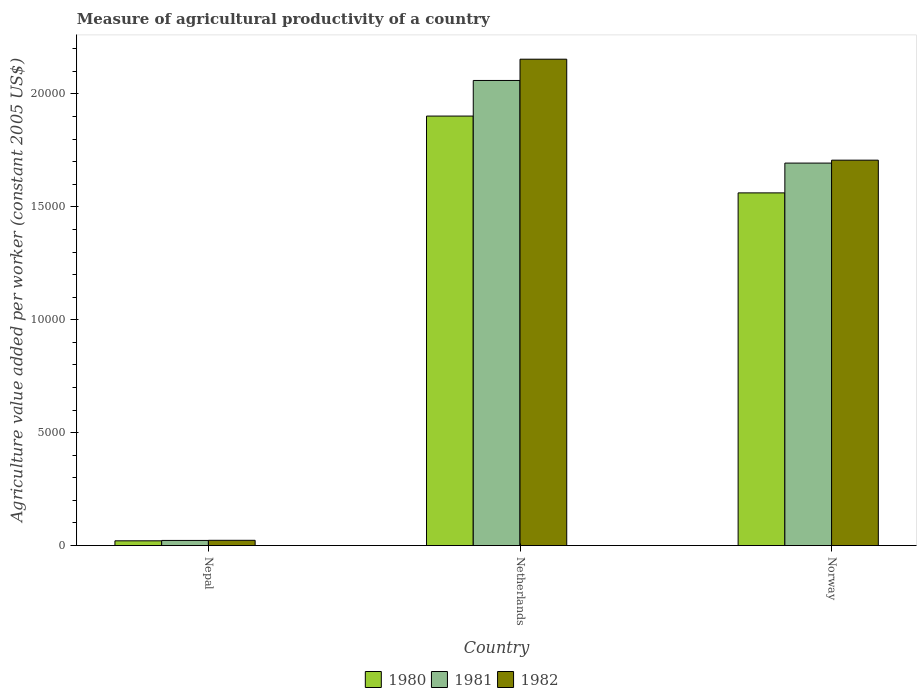How many different coloured bars are there?
Your response must be concise. 3. Are the number of bars per tick equal to the number of legend labels?
Your answer should be very brief. Yes. How many bars are there on the 2nd tick from the left?
Provide a short and direct response. 3. How many bars are there on the 2nd tick from the right?
Offer a terse response. 3. What is the label of the 1st group of bars from the left?
Your answer should be compact. Nepal. In how many cases, is the number of bars for a given country not equal to the number of legend labels?
Your response must be concise. 0. What is the measure of agricultural productivity in 1980 in Nepal?
Provide a short and direct response. 210.09. Across all countries, what is the maximum measure of agricultural productivity in 1981?
Offer a very short reply. 2.06e+04. Across all countries, what is the minimum measure of agricultural productivity in 1982?
Ensure brevity in your answer.  232.83. In which country was the measure of agricultural productivity in 1982 minimum?
Provide a short and direct response. Nepal. What is the total measure of agricultural productivity in 1982 in the graph?
Your response must be concise. 3.88e+04. What is the difference between the measure of agricultural productivity in 1981 in Nepal and that in Netherlands?
Provide a succinct answer. -2.04e+04. What is the difference between the measure of agricultural productivity in 1982 in Nepal and the measure of agricultural productivity in 1981 in Norway?
Make the answer very short. -1.67e+04. What is the average measure of agricultural productivity in 1980 per country?
Your answer should be very brief. 1.16e+04. What is the difference between the measure of agricultural productivity of/in 1982 and measure of agricultural productivity of/in 1980 in Nepal?
Offer a terse response. 22.74. What is the ratio of the measure of agricultural productivity in 1982 in Netherlands to that in Norway?
Keep it short and to the point. 1.26. Is the measure of agricultural productivity in 1980 in Nepal less than that in Netherlands?
Offer a terse response. Yes. What is the difference between the highest and the second highest measure of agricultural productivity in 1980?
Keep it short and to the point. 1.54e+04. What is the difference between the highest and the lowest measure of agricultural productivity in 1982?
Your response must be concise. 2.13e+04. In how many countries, is the measure of agricultural productivity in 1981 greater than the average measure of agricultural productivity in 1981 taken over all countries?
Ensure brevity in your answer.  2. What does the 1st bar from the right in Netherlands represents?
Give a very brief answer. 1982. Is it the case that in every country, the sum of the measure of agricultural productivity in 1981 and measure of agricultural productivity in 1980 is greater than the measure of agricultural productivity in 1982?
Your answer should be very brief. Yes. Are all the bars in the graph horizontal?
Offer a terse response. No. Does the graph contain any zero values?
Your response must be concise. No. Does the graph contain grids?
Make the answer very short. No. Where does the legend appear in the graph?
Provide a short and direct response. Bottom center. How are the legend labels stacked?
Ensure brevity in your answer.  Horizontal. What is the title of the graph?
Keep it short and to the point. Measure of agricultural productivity of a country. Does "2013" appear as one of the legend labels in the graph?
Provide a short and direct response. No. What is the label or title of the X-axis?
Your response must be concise. Country. What is the label or title of the Y-axis?
Your response must be concise. Agriculture value added per worker (constant 2005 US$). What is the Agriculture value added per worker (constant 2005 US$) of 1980 in Nepal?
Your answer should be very brief. 210.09. What is the Agriculture value added per worker (constant 2005 US$) of 1981 in Nepal?
Your answer should be very brief. 227.07. What is the Agriculture value added per worker (constant 2005 US$) in 1982 in Nepal?
Ensure brevity in your answer.  232.83. What is the Agriculture value added per worker (constant 2005 US$) in 1980 in Netherlands?
Provide a short and direct response. 1.90e+04. What is the Agriculture value added per worker (constant 2005 US$) of 1981 in Netherlands?
Offer a very short reply. 2.06e+04. What is the Agriculture value added per worker (constant 2005 US$) of 1982 in Netherlands?
Make the answer very short. 2.15e+04. What is the Agriculture value added per worker (constant 2005 US$) of 1980 in Norway?
Your answer should be compact. 1.56e+04. What is the Agriculture value added per worker (constant 2005 US$) in 1981 in Norway?
Your answer should be very brief. 1.69e+04. What is the Agriculture value added per worker (constant 2005 US$) of 1982 in Norway?
Your answer should be compact. 1.71e+04. Across all countries, what is the maximum Agriculture value added per worker (constant 2005 US$) in 1980?
Ensure brevity in your answer.  1.90e+04. Across all countries, what is the maximum Agriculture value added per worker (constant 2005 US$) of 1981?
Ensure brevity in your answer.  2.06e+04. Across all countries, what is the maximum Agriculture value added per worker (constant 2005 US$) in 1982?
Offer a very short reply. 2.15e+04. Across all countries, what is the minimum Agriculture value added per worker (constant 2005 US$) of 1980?
Offer a very short reply. 210.09. Across all countries, what is the minimum Agriculture value added per worker (constant 2005 US$) of 1981?
Make the answer very short. 227.07. Across all countries, what is the minimum Agriculture value added per worker (constant 2005 US$) in 1982?
Offer a terse response. 232.83. What is the total Agriculture value added per worker (constant 2005 US$) in 1980 in the graph?
Your response must be concise. 3.48e+04. What is the total Agriculture value added per worker (constant 2005 US$) of 1981 in the graph?
Give a very brief answer. 3.78e+04. What is the total Agriculture value added per worker (constant 2005 US$) of 1982 in the graph?
Keep it short and to the point. 3.88e+04. What is the difference between the Agriculture value added per worker (constant 2005 US$) in 1980 in Nepal and that in Netherlands?
Your response must be concise. -1.88e+04. What is the difference between the Agriculture value added per worker (constant 2005 US$) in 1981 in Nepal and that in Netherlands?
Provide a short and direct response. -2.04e+04. What is the difference between the Agriculture value added per worker (constant 2005 US$) in 1982 in Nepal and that in Netherlands?
Make the answer very short. -2.13e+04. What is the difference between the Agriculture value added per worker (constant 2005 US$) in 1980 in Nepal and that in Norway?
Your response must be concise. -1.54e+04. What is the difference between the Agriculture value added per worker (constant 2005 US$) of 1981 in Nepal and that in Norway?
Your answer should be very brief. -1.67e+04. What is the difference between the Agriculture value added per worker (constant 2005 US$) in 1982 in Nepal and that in Norway?
Ensure brevity in your answer.  -1.68e+04. What is the difference between the Agriculture value added per worker (constant 2005 US$) of 1980 in Netherlands and that in Norway?
Your answer should be compact. 3401.71. What is the difference between the Agriculture value added per worker (constant 2005 US$) in 1981 in Netherlands and that in Norway?
Make the answer very short. 3658.56. What is the difference between the Agriculture value added per worker (constant 2005 US$) in 1982 in Netherlands and that in Norway?
Keep it short and to the point. 4471.16. What is the difference between the Agriculture value added per worker (constant 2005 US$) in 1980 in Nepal and the Agriculture value added per worker (constant 2005 US$) in 1981 in Netherlands?
Provide a short and direct response. -2.04e+04. What is the difference between the Agriculture value added per worker (constant 2005 US$) of 1980 in Nepal and the Agriculture value added per worker (constant 2005 US$) of 1982 in Netherlands?
Your answer should be compact. -2.13e+04. What is the difference between the Agriculture value added per worker (constant 2005 US$) in 1981 in Nepal and the Agriculture value added per worker (constant 2005 US$) in 1982 in Netherlands?
Your answer should be very brief. -2.13e+04. What is the difference between the Agriculture value added per worker (constant 2005 US$) of 1980 in Nepal and the Agriculture value added per worker (constant 2005 US$) of 1981 in Norway?
Make the answer very short. -1.67e+04. What is the difference between the Agriculture value added per worker (constant 2005 US$) of 1980 in Nepal and the Agriculture value added per worker (constant 2005 US$) of 1982 in Norway?
Offer a very short reply. -1.69e+04. What is the difference between the Agriculture value added per worker (constant 2005 US$) of 1981 in Nepal and the Agriculture value added per worker (constant 2005 US$) of 1982 in Norway?
Make the answer very short. -1.68e+04. What is the difference between the Agriculture value added per worker (constant 2005 US$) of 1980 in Netherlands and the Agriculture value added per worker (constant 2005 US$) of 1981 in Norway?
Give a very brief answer. 2081.76. What is the difference between the Agriculture value added per worker (constant 2005 US$) of 1980 in Netherlands and the Agriculture value added per worker (constant 2005 US$) of 1982 in Norway?
Offer a terse response. 1952.22. What is the difference between the Agriculture value added per worker (constant 2005 US$) of 1981 in Netherlands and the Agriculture value added per worker (constant 2005 US$) of 1982 in Norway?
Provide a succinct answer. 3529.02. What is the average Agriculture value added per worker (constant 2005 US$) in 1980 per country?
Offer a terse response. 1.16e+04. What is the average Agriculture value added per worker (constant 2005 US$) in 1981 per country?
Your answer should be very brief. 1.26e+04. What is the average Agriculture value added per worker (constant 2005 US$) in 1982 per country?
Provide a short and direct response. 1.29e+04. What is the difference between the Agriculture value added per worker (constant 2005 US$) in 1980 and Agriculture value added per worker (constant 2005 US$) in 1981 in Nepal?
Give a very brief answer. -16.98. What is the difference between the Agriculture value added per worker (constant 2005 US$) in 1980 and Agriculture value added per worker (constant 2005 US$) in 1982 in Nepal?
Offer a very short reply. -22.74. What is the difference between the Agriculture value added per worker (constant 2005 US$) of 1981 and Agriculture value added per worker (constant 2005 US$) of 1982 in Nepal?
Provide a succinct answer. -5.76. What is the difference between the Agriculture value added per worker (constant 2005 US$) in 1980 and Agriculture value added per worker (constant 2005 US$) in 1981 in Netherlands?
Give a very brief answer. -1576.8. What is the difference between the Agriculture value added per worker (constant 2005 US$) of 1980 and Agriculture value added per worker (constant 2005 US$) of 1982 in Netherlands?
Provide a succinct answer. -2518.94. What is the difference between the Agriculture value added per worker (constant 2005 US$) of 1981 and Agriculture value added per worker (constant 2005 US$) of 1982 in Netherlands?
Provide a succinct answer. -942.14. What is the difference between the Agriculture value added per worker (constant 2005 US$) in 1980 and Agriculture value added per worker (constant 2005 US$) in 1981 in Norway?
Your answer should be very brief. -1319.95. What is the difference between the Agriculture value added per worker (constant 2005 US$) in 1980 and Agriculture value added per worker (constant 2005 US$) in 1982 in Norway?
Provide a succinct answer. -1449.49. What is the difference between the Agriculture value added per worker (constant 2005 US$) in 1981 and Agriculture value added per worker (constant 2005 US$) in 1982 in Norway?
Your answer should be very brief. -129.54. What is the ratio of the Agriculture value added per worker (constant 2005 US$) in 1980 in Nepal to that in Netherlands?
Your answer should be very brief. 0.01. What is the ratio of the Agriculture value added per worker (constant 2005 US$) in 1981 in Nepal to that in Netherlands?
Ensure brevity in your answer.  0.01. What is the ratio of the Agriculture value added per worker (constant 2005 US$) of 1982 in Nepal to that in Netherlands?
Your answer should be compact. 0.01. What is the ratio of the Agriculture value added per worker (constant 2005 US$) in 1980 in Nepal to that in Norway?
Your response must be concise. 0.01. What is the ratio of the Agriculture value added per worker (constant 2005 US$) of 1981 in Nepal to that in Norway?
Offer a very short reply. 0.01. What is the ratio of the Agriculture value added per worker (constant 2005 US$) in 1982 in Nepal to that in Norway?
Keep it short and to the point. 0.01. What is the ratio of the Agriculture value added per worker (constant 2005 US$) in 1980 in Netherlands to that in Norway?
Provide a short and direct response. 1.22. What is the ratio of the Agriculture value added per worker (constant 2005 US$) in 1981 in Netherlands to that in Norway?
Ensure brevity in your answer.  1.22. What is the ratio of the Agriculture value added per worker (constant 2005 US$) in 1982 in Netherlands to that in Norway?
Offer a terse response. 1.26. What is the difference between the highest and the second highest Agriculture value added per worker (constant 2005 US$) in 1980?
Your response must be concise. 3401.71. What is the difference between the highest and the second highest Agriculture value added per worker (constant 2005 US$) in 1981?
Keep it short and to the point. 3658.56. What is the difference between the highest and the second highest Agriculture value added per worker (constant 2005 US$) in 1982?
Your response must be concise. 4471.16. What is the difference between the highest and the lowest Agriculture value added per worker (constant 2005 US$) of 1980?
Your answer should be very brief. 1.88e+04. What is the difference between the highest and the lowest Agriculture value added per worker (constant 2005 US$) in 1981?
Provide a succinct answer. 2.04e+04. What is the difference between the highest and the lowest Agriculture value added per worker (constant 2005 US$) in 1982?
Offer a very short reply. 2.13e+04. 